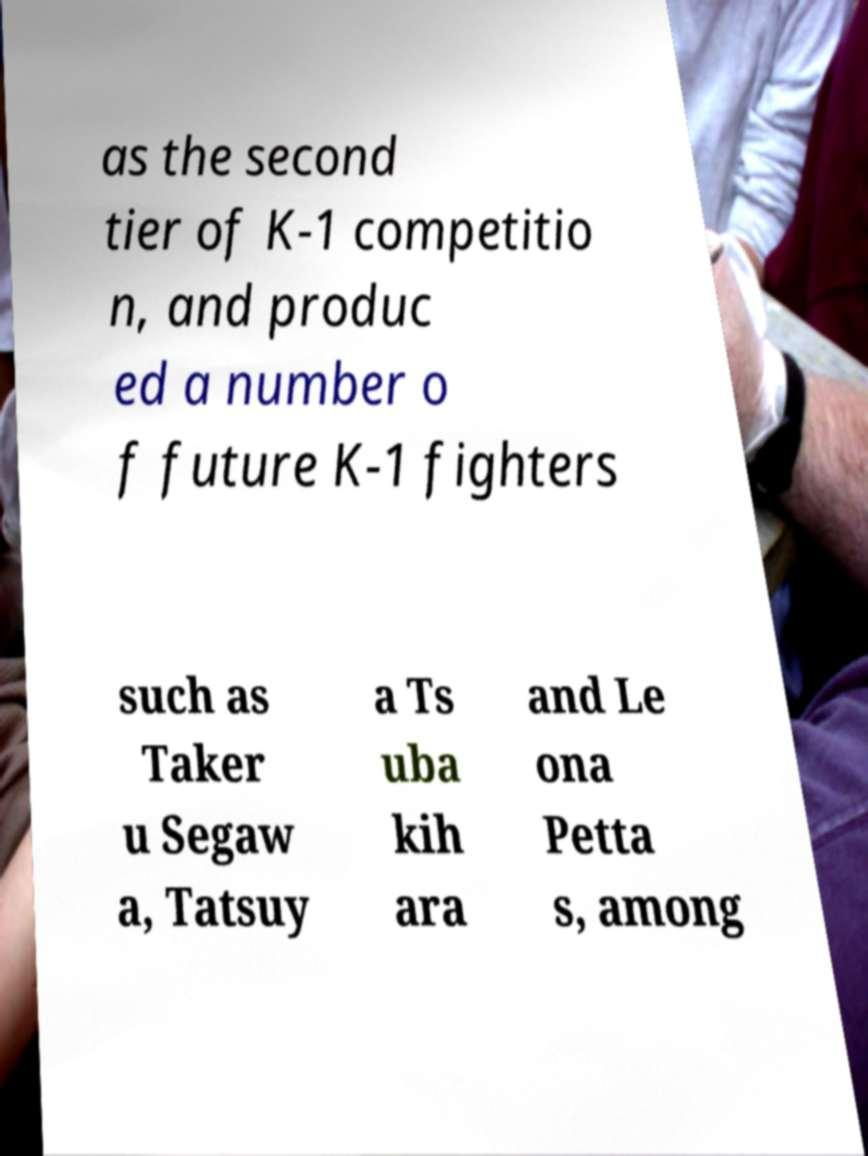Please read and relay the text visible in this image. What does it say? as the second tier of K-1 competitio n, and produc ed a number o f future K-1 fighters such as Taker u Segaw a, Tatsuy a Ts uba kih ara and Le ona Petta s, among 